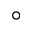<formula> <loc_0><loc_0><loc_500><loc_500>^ { \circ }</formula> 